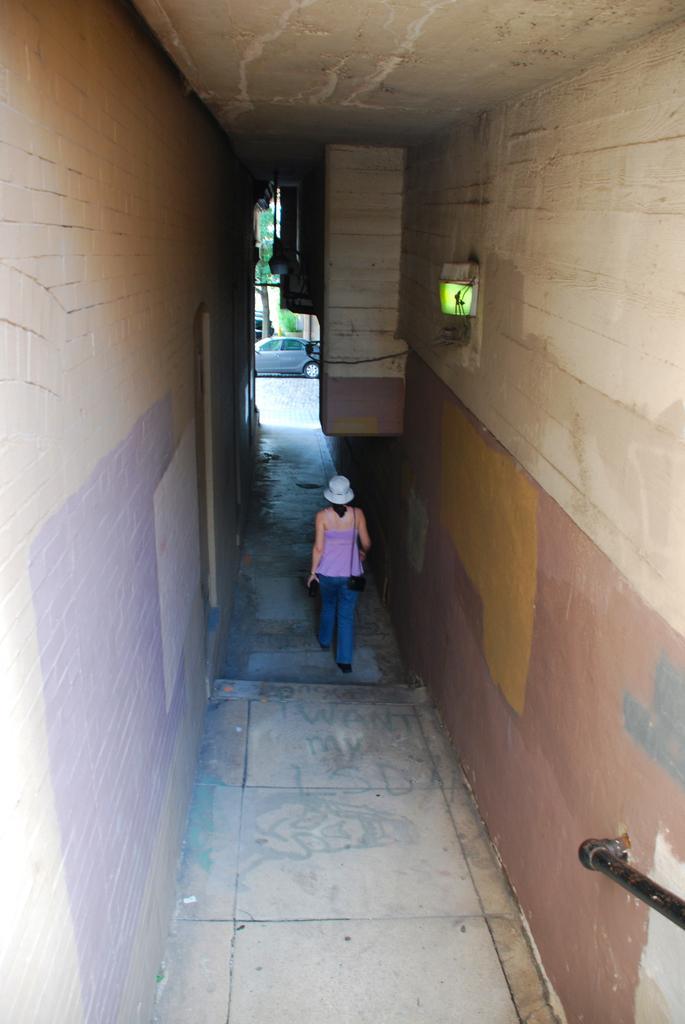Please provide a concise description of this image. In this picture we can see a woman wearing a cap and a bag. She is walking on the path. We can see some text and an art on the path. There are walls visible on both sides of the path. We can see a light visible on the wall on the right side. There is a rod seen on the right side. We can see a vehicle, tree and other things in the background. 